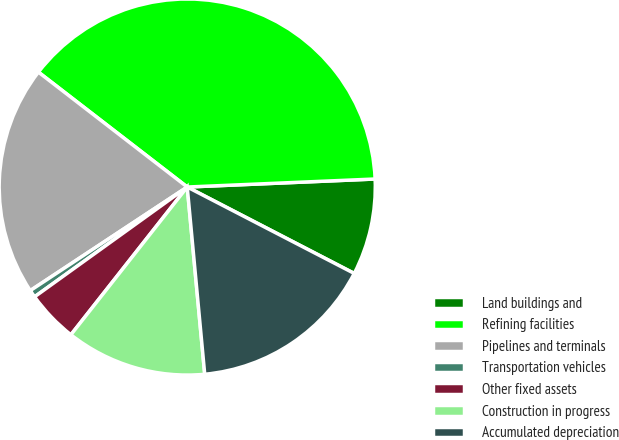<chart> <loc_0><loc_0><loc_500><loc_500><pie_chart><fcel>Land buildings and<fcel>Refining facilities<fcel>Pipelines and terminals<fcel>Transportation vehicles<fcel>Other fixed assets<fcel>Construction in progress<fcel>Accumulated depreciation<nl><fcel>8.28%<fcel>38.86%<fcel>19.75%<fcel>0.64%<fcel>4.46%<fcel>12.1%<fcel>15.92%<nl></chart> 